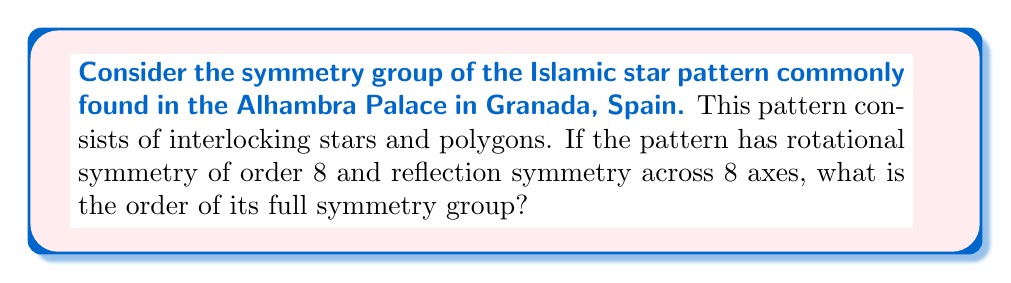Teach me how to tackle this problem. To solve this problem, we need to understand the concept of dihedral groups and how they relate to symmetries in art and architecture.

1. The given pattern has rotational symmetry of order 8, meaning it can be rotated by multiples of 45° (360°/8) and remain unchanged.

2. It also has 8 reflection axes, which means there are 8 lines across which the pattern can be reflected and remain unchanged.

3. This combination of rotational and reflection symmetries forms a dihedral group, denoted as $D_8$.

4. The order of a dihedral group $D_n$ is given by the formula:

   $$|D_n| = 2n$$

   Where $n$ is the order of rotational symmetry.

5. In this case, $n = 8$, so we have:

   $$|D_8| = 2 \cdot 8 = 16$$

6. To understand why this is true, we can break down the symmetries:
   - There are 8 rotational symmetries (including the identity rotation)
   - There are 8 reflection symmetries

7. The total number of symmetries is the sum of these: 8 + 8 = 16

Therefore, the order of the full symmetry group of this Islamic star pattern is 16.
Answer: The order of the full symmetry group is 16. 